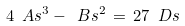<formula> <loc_0><loc_0><loc_500><loc_500>4 \ A s ^ { 3 } - \ B s ^ { 2 } \, = \, 2 7 \ D s</formula> 